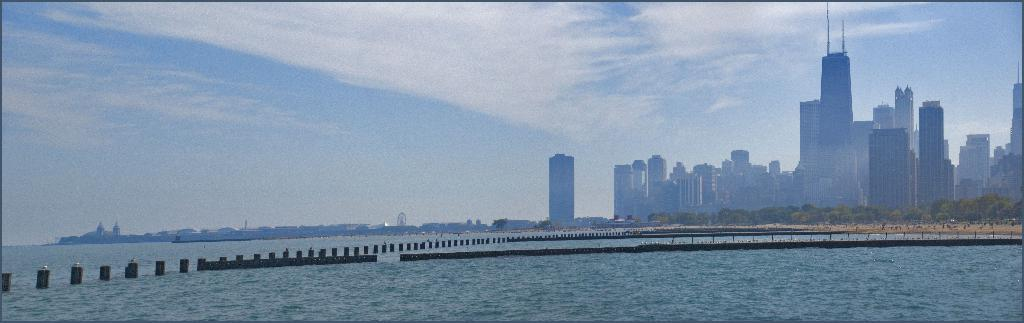What is visible in the image that is not a solid structure? Water is visible in the image. What type of natural vegetation can be seen in the image? There are trees in the image. What type of man-made structures are present in the image? There are buildings in the image. What is visible in the background of the image? The sky is visible in the image. What can be seen in the sky in the image? Clouds are present in the sky. What discovery was made by the mist in the image? There is no mist present in the image, and therefore no discovery can be attributed to it. How does the mind influence the clouds in the image? The image does not depict any influence of the mind on the clouds, as it is a visual representation of the physical world. 